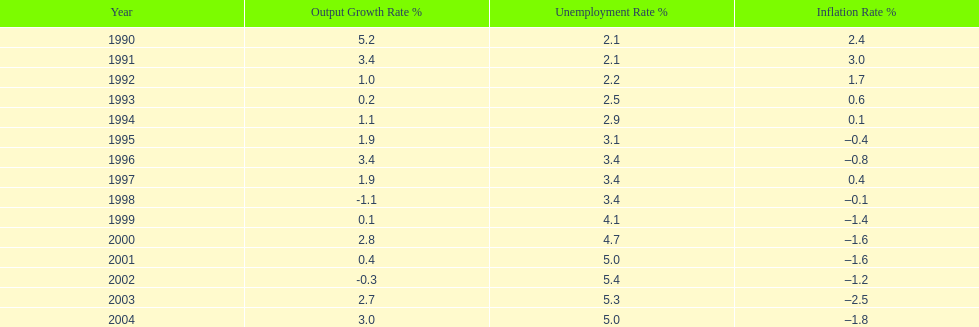When in the 1990's did the inflation rate first become negative? 1995. 